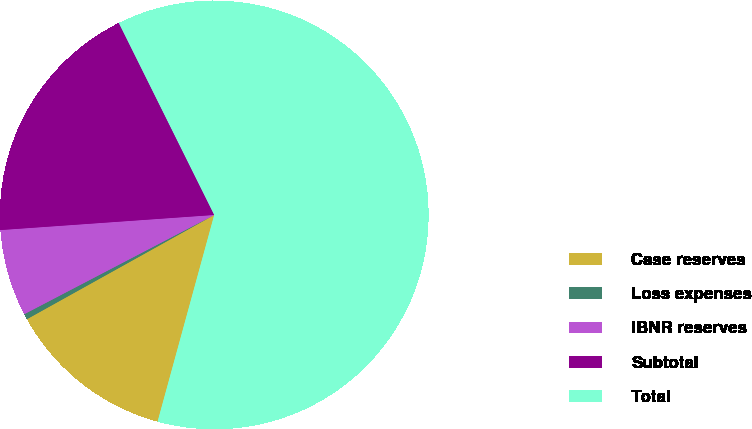<chart> <loc_0><loc_0><loc_500><loc_500><pie_chart><fcel>Case reserves<fcel>Loss expenses<fcel>IBNR reserves<fcel>Subtotal<fcel>Total<nl><fcel>12.66%<fcel>0.42%<fcel>6.54%<fcel>18.78%<fcel>61.6%<nl></chart> 